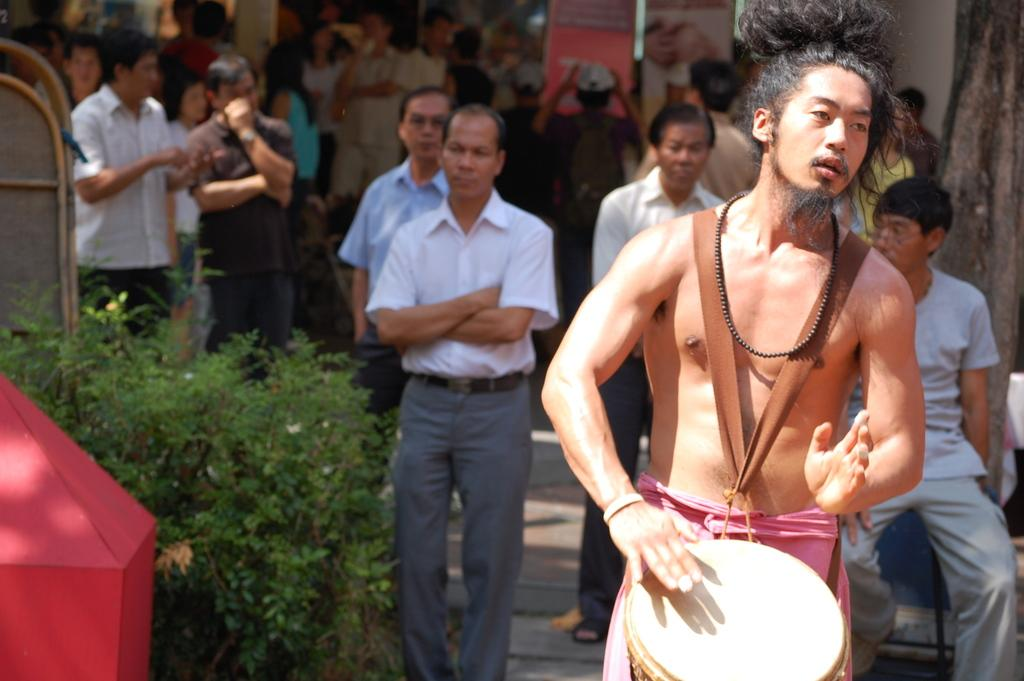How many people are in the image? There are people in the image, but the exact number is not specified. What is the man doing in the image? The man is playing a drum in the image. What celestial bodies can be seen in the image? There are planets visible in the image. What type of objects are present in the image? There are objects in the image, but their specific nature is not mentioned. What natural element is present in the image? A tree trunk is present in the image. What architectural feature can be seen in the background of the image? There are boards in the background of the image. What type of pipe is being used to transport the substance in the image? There is no pipe or substance present in the image. 